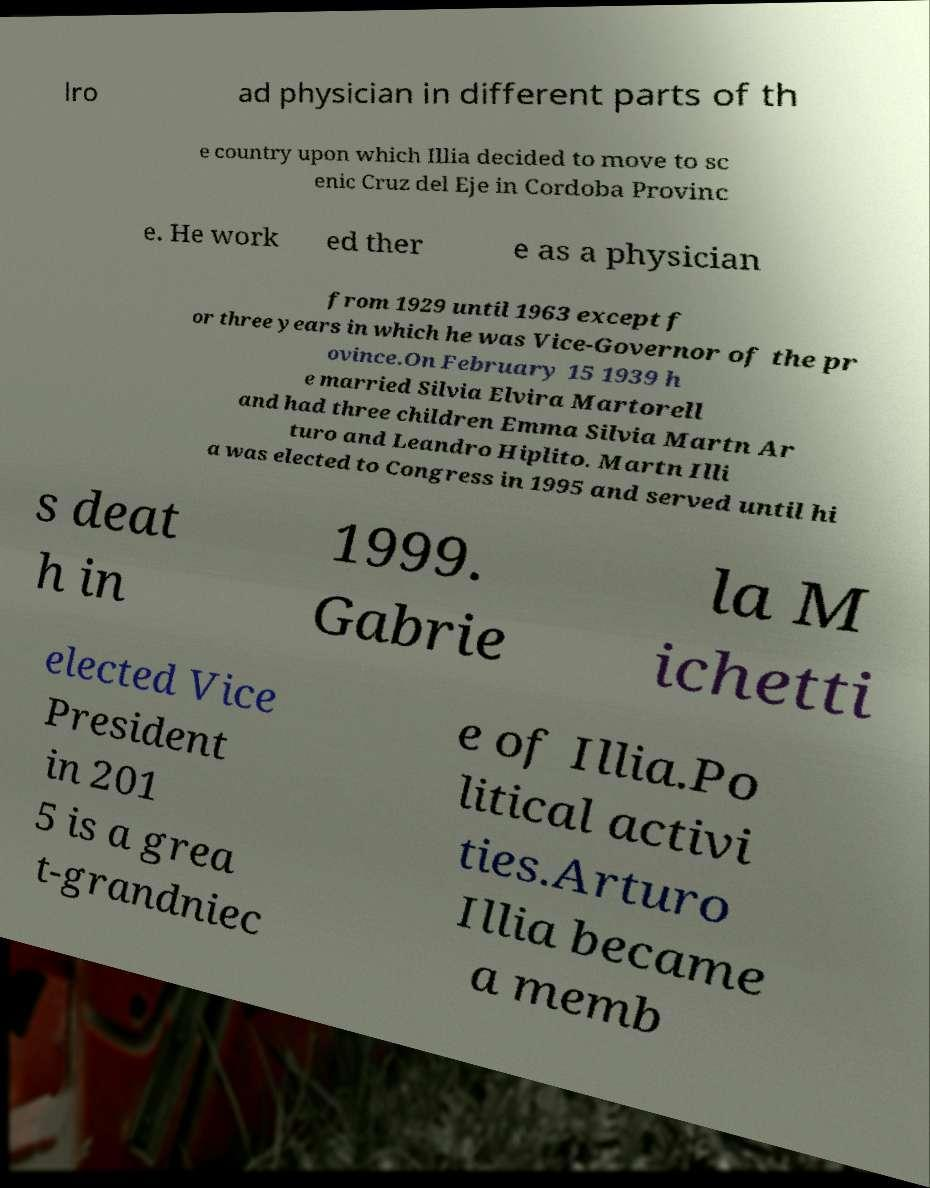Please read and relay the text visible in this image. What does it say? lro ad physician in different parts of th e country upon which Illia decided to move to sc enic Cruz del Eje in Cordoba Provinc e. He work ed ther e as a physician from 1929 until 1963 except f or three years in which he was Vice-Governor of the pr ovince.On February 15 1939 h e married Silvia Elvira Martorell and had three children Emma Silvia Martn Ar turo and Leandro Hiplito. Martn Illi a was elected to Congress in 1995 and served until hi s deat h in 1999. Gabrie la M ichetti elected Vice President in 201 5 is a grea t-grandniec e of Illia.Po litical activi ties.Arturo Illia became a memb 